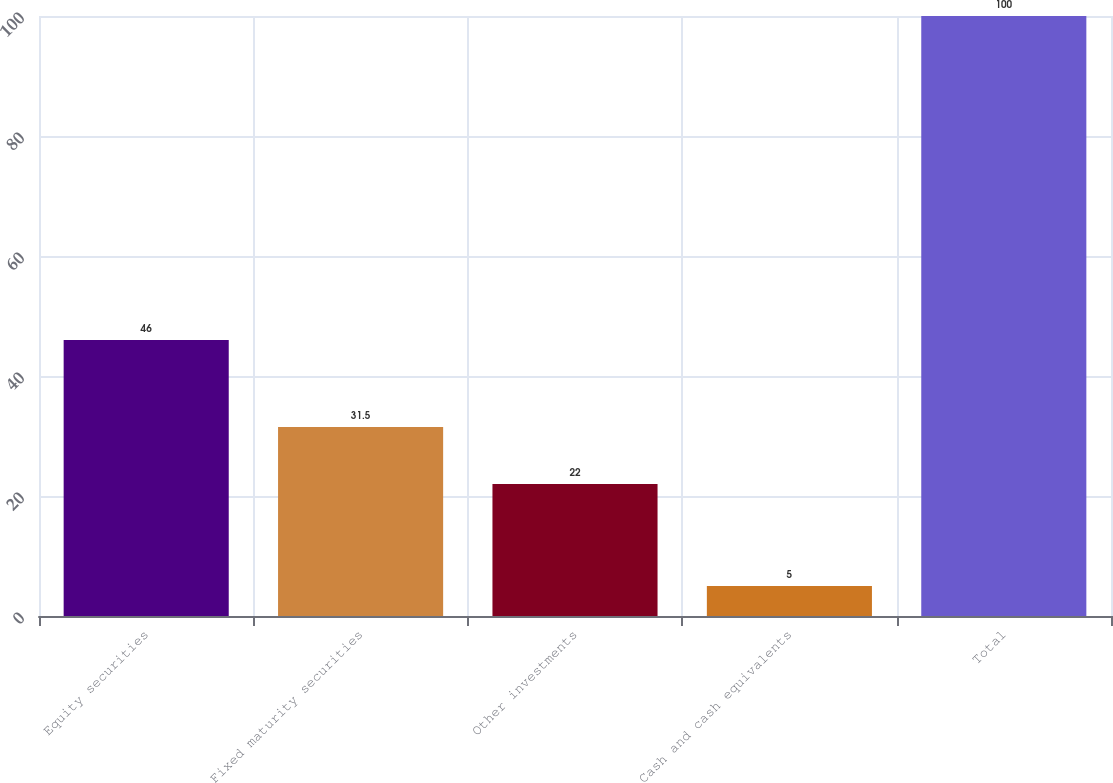Convert chart to OTSL. <chart><loc_0><loc_0><loc_500><loc_500><bar_chart><fcel>Equity securities<fcel>Fixed maturity securities<fcel>Other investments<fcel>Cash and cash equivalents<fcel>Total<nl><fcel>46<fcel>31.5<fcel>22<fcel>5<fcel>100<nl></chart> 